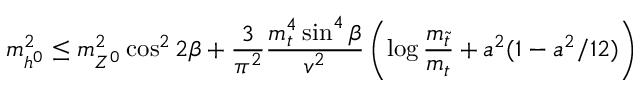<formula> <loc_0><loc_0><loc_500><loc_500>m _ { h ^ { 0 } } ^ { 2 } \leq m _ { Z ^ { 0 } } ^ { 2 } \cos ^ { 2 } 2 \beta + { \frac { 3 } { \pi ^ { 2 } } } { \frac { m _ { t } ^ { 4 } \sin ^ { 4 } \beta } { v ^ { 2 } } } \left ( \log { \frac { m _ { \tilde { t } } } { m _ { t } } } + a ^ { 2 } ( 1 - a ^ { 2 } / 1 2 ) \right )</formula> 